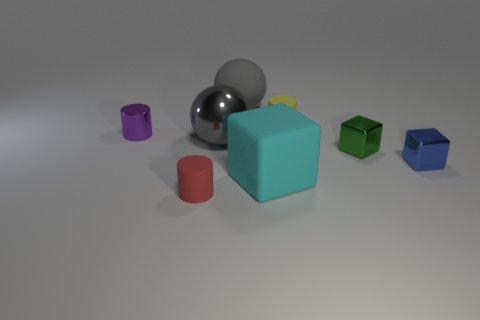Subtract all red rubber cylinders. How many cylinders are left? 2 Subtract 1 cubes. How many cubes are left? 2 Add 2 big rubber objects. How many objects exist? 10 Subtract all cylinders. How many objects are left? 5 Add 1 small green metallic cubes. How many small green metallic cubes are left? 2 Add 8 tiny brown rubber cubes. How many tiny brown rubber cubes exist? 8 Subtract 0 cyan cylinders. How many objects are left? 8 Subtract all tiny green rubber blocks. Subtract all tiny rubber cylinders. How many objects are left? 6 